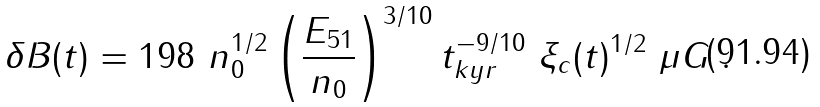<formula> <loc_0><loc_0><loc_500><loc_500>\delta B ( t ) = 1 9 8 \ n _ { 0 } ^ { 1 / 2 } \left ( \frac { E _ { 5 1 } } { n _ { 0 } } \right ) ^ { 3 / 1 0 } t _ { k y r } ^ { - 9 / 1 0 } \ \xi _ { c } ( t ) ^ { 1 / 2 } \ \mu G \ .</formula> 